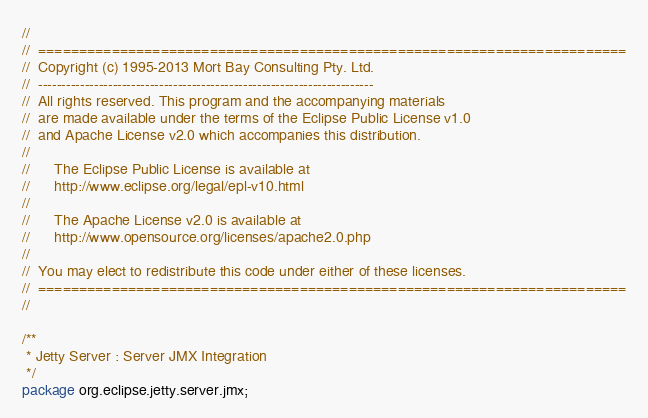<code> <loc_0><loc_0><loc_500><loc_500><_Java_>//
//  ========================================================================
//  Copyright (c) 1995-2013 Mort Bay Consulting Pty. Ltd.
//  ------------------------------------------------------------------------
//  All rights reserved. This program and the accompanying materials
//  are made available under the terms of the Eclipse Public License v1.0
//  and Apache License v2.0 which accompanies this distribution.
//
//      The Eclipse Public License is available at
//      http://www.eclipse.org/legal/epl-v10.html
//
//      The Apache License v2.0 is available at
//      http://www.opensource.org/licenses/apache2.0.php
//
//  You may elect to redistribute this code under either of these licenses.
//  ========================================================================
//

/**
 * Jetty Server : Server JMX Integration
 */
package org.eclipse.jetty.server.jmx;

</code> 